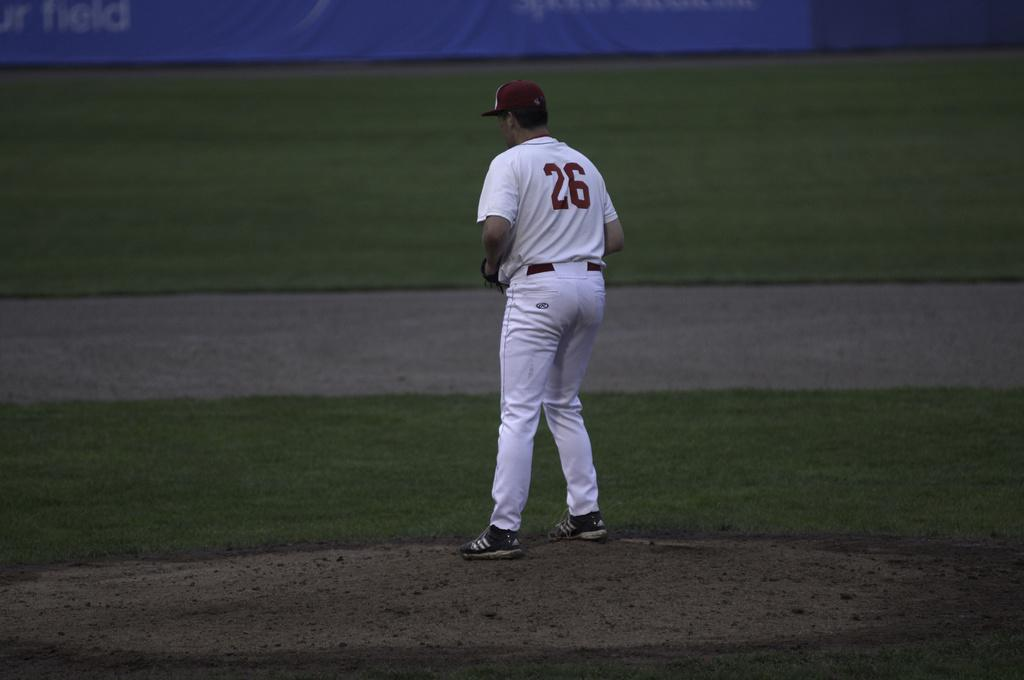Provide a one-sentence caption for the provided image. Baseball player number 26 stands on the pitcher's mound. 